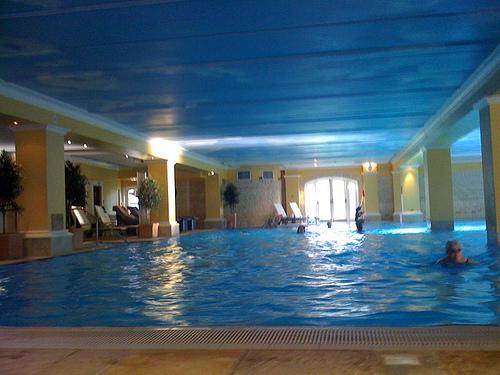How many people?
Keep it brief. 4. Is this pool outside?
Give a very brief answer. No. Is this an ocean?
Short answer required. No. 